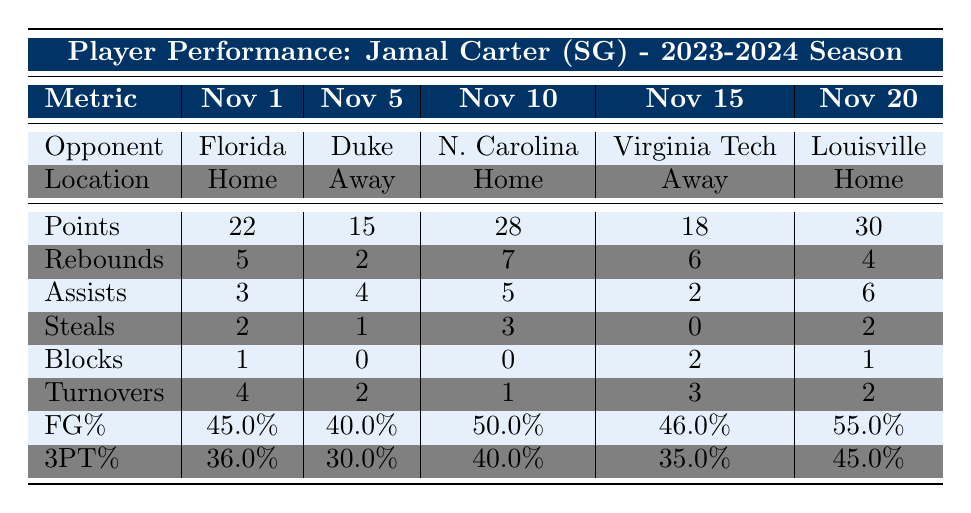What was Jamal Carter's highest point total in a game? In the table, the points scored by Jamal Carter in each game are 22, 15, 28, 18, and 30. Out of these values, 30 is the highest.
Answer: 30 What game had the lowest field goal percentage? The field goal percentages for each game are 45.0%, 40.0%, 50.0%, 46.0%, and 55.0%. The lowest percentage is 40.0% from the game against Duke University.
Answer: 40.0% How many total assists did Jamal Carter record across all games? The assists recorded in each game are 3, 4, 5, 2, and 6. Adding these gives a total of 3 + 4 + 5 + 2 + 6 = 20 assists.
Answer: 20 Did Jamal Carter have more rebounds at home or away games? Viewing the rebounds in home games (5, 7, 4) and away games (2, 6), the sum for home is 16 and for away is 8. This indicates he had more rebounds in home games.
Answer: Yes What was Jamal Carter's average three-point percentage for the season? The three-point percentages are 36.0%, 30.0%, 40.0%, 35.0%, and 45.0%. First, sum these percentages: 36.0 + 30.0 + 40.0 + 35.0 + 45.0 = 186.0. Then divide by the number of games (5): 186.0 / 5 = 37.2%.
Answer: 37.2% How many steals did Jamal Carter record in his game against North Carolina? The table shows that he recorded 3 steals in the game against North Carolina.
Answer: 3 What is the game with the highest number of turnovers? The turnovers in each game are 4, 2, 1, 3, and 2. The highest number of turnovers is 4 in the game against Florida.
Answer: 4 Which game did Jamal Carter achieve his highest number of assists? The assists listed are 3, 4, 5, 2, and 6. The highest value, 6, occurred during the game against Louisville.
Answer: Louisville 